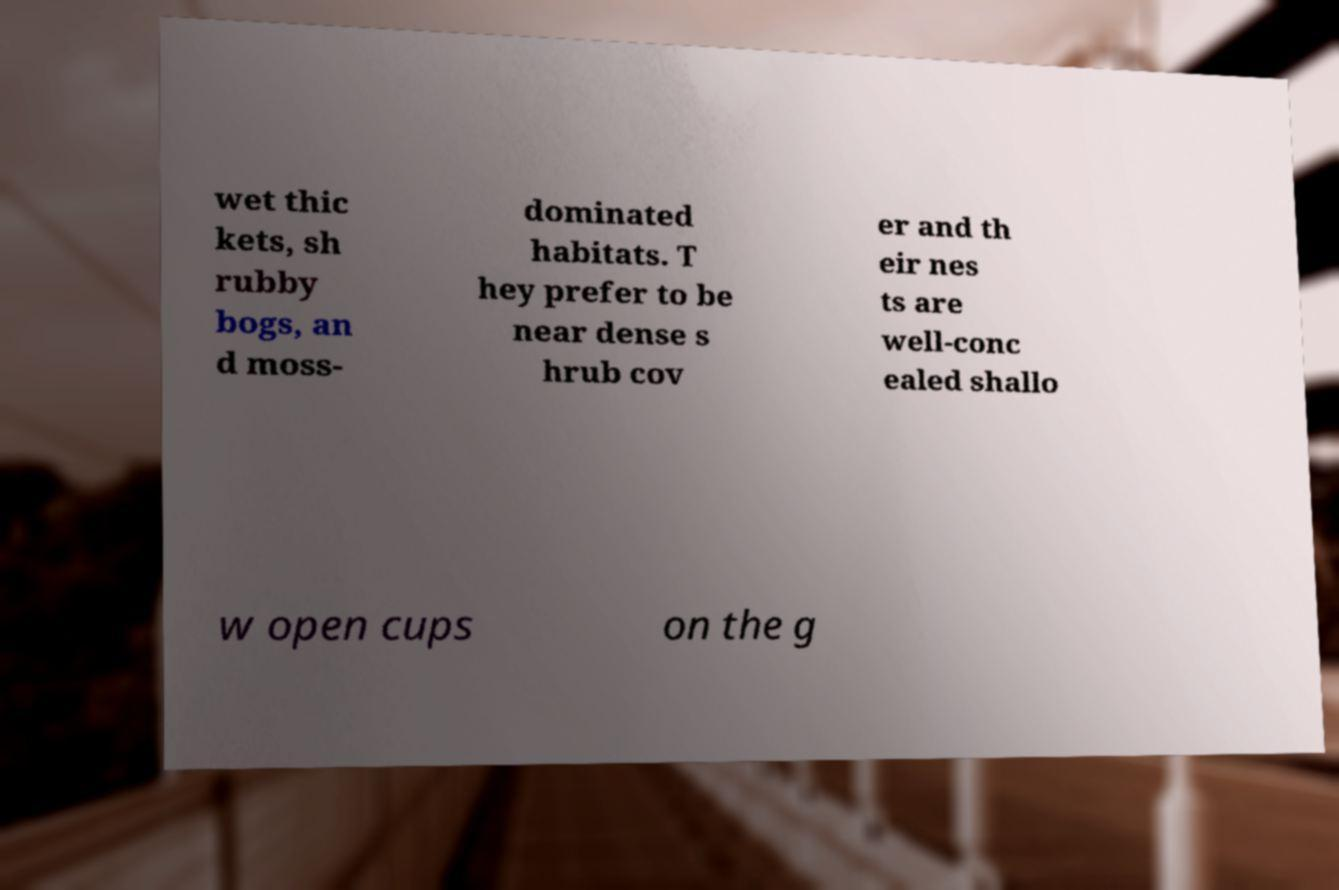Could you extract and type out the text from this image? wet thic kets, sh rubby bogs, an d moss- dominated habitats. T hey prefer to be near dense s hrub cov er and th eir nes ts are well-conc ealed shallo w open cups on the g 